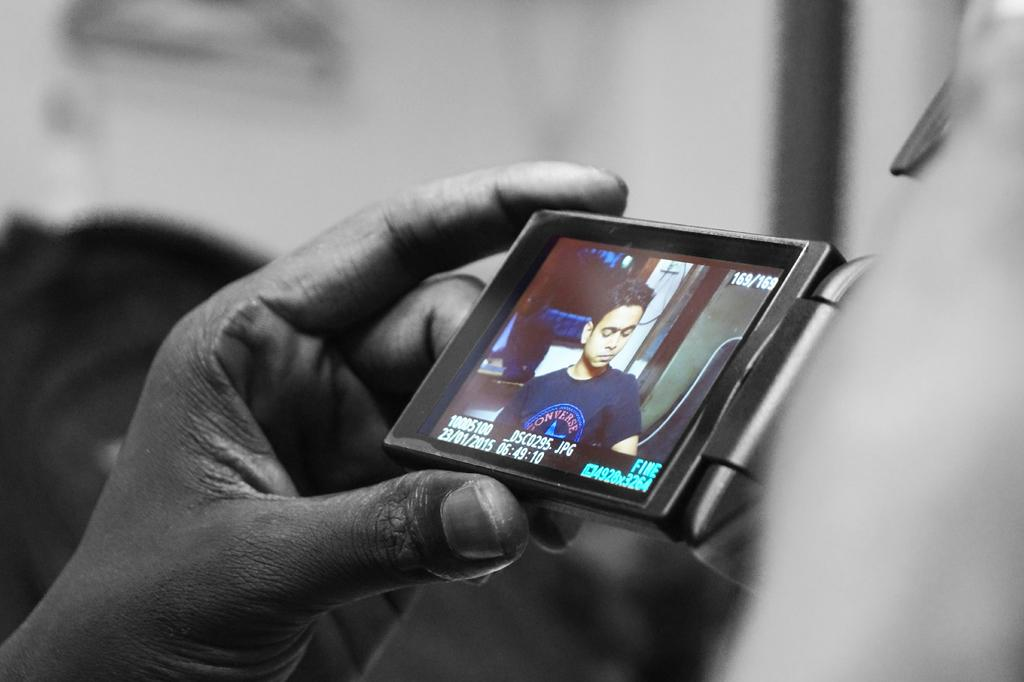What is the main object being held in the image? A human hand is holding a camera in the image. What feature does the camera have? The camera has a screen. What can be seen on the screen of the camera? A person is visible on the screen. How would you describe the background of the image? The background of the image appears to be white and black in color. What type of horn is being played by the person on the camera's screen? There is no horn visible in the image, as the person on the screen is not playing any instrument. Can you describe the elbow of the person holding the camera? The elbow of the person holding the camera is not visible in the image, as only their hand and the camera are shown. 